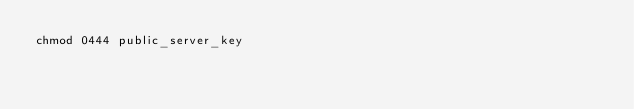<code> <loc_0><loc_0><loc_500><loc_500><_Bash_>chmod 0444 public_server_key
</code> 